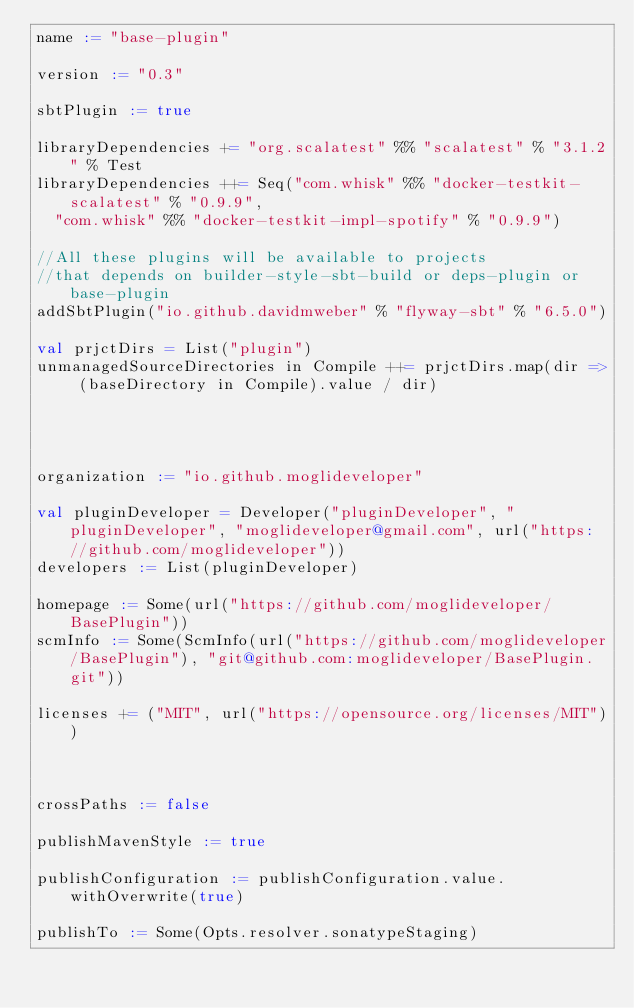<code> <loc_0><loc_0><loc_500><loc_500><_Scala_>name := "base-plugin"

version := "0.3"

sbtPlugin := true

libraryDependencies += "org.scalatest" %% "scalatest" % "3.1.2" % Test
libraryDependencies ++= Seq("com.whisk" %% "docker-testkit-scalatest" % "0.9.9",
  "com.whisk" %% "docker-testkit-impl-spotify" % "0.9.9")

//All these plugins will be available to projects
//that depends on builder-style-sbt-build or deps-plugin or base-plugin
addSbtPlugin("io.github.davidmweber" % "flyway-sbt" % "6.5.0")

val prjctDirs = List("plugin")
unmanagedSourceDirectories in Compile ++= prjctDirs.map(dir => (baseDirectory in Compile).value / dir)




organization := "io.github.moglideveloper"

val pluginDeveloper = Developer("pluginDeveloper", "pluginDeveloper", "moglideveloper@gmail.com", url("https://github.com/moglideveloper"))
developers := List(pluginDeveloper)

homepage := Some(url("https://github.com/moglideveloper/BasePlugin"))
scmInfo := Some(ScmInfo(url("https://github.com/moglideveloper/BasePlugin"), "git@github.com:moglideveloper/BasePlugin.git"))

licenses += ("MIT", url("https://opensource.org/licenses/MIT"))



crossPaths := false

publishMavenStyle := true

publishConfiguration := publishConfiguration.value.withOverwrite(true)

publishTo := Some(Opts.resolver.sonatypeStaging)</code> 